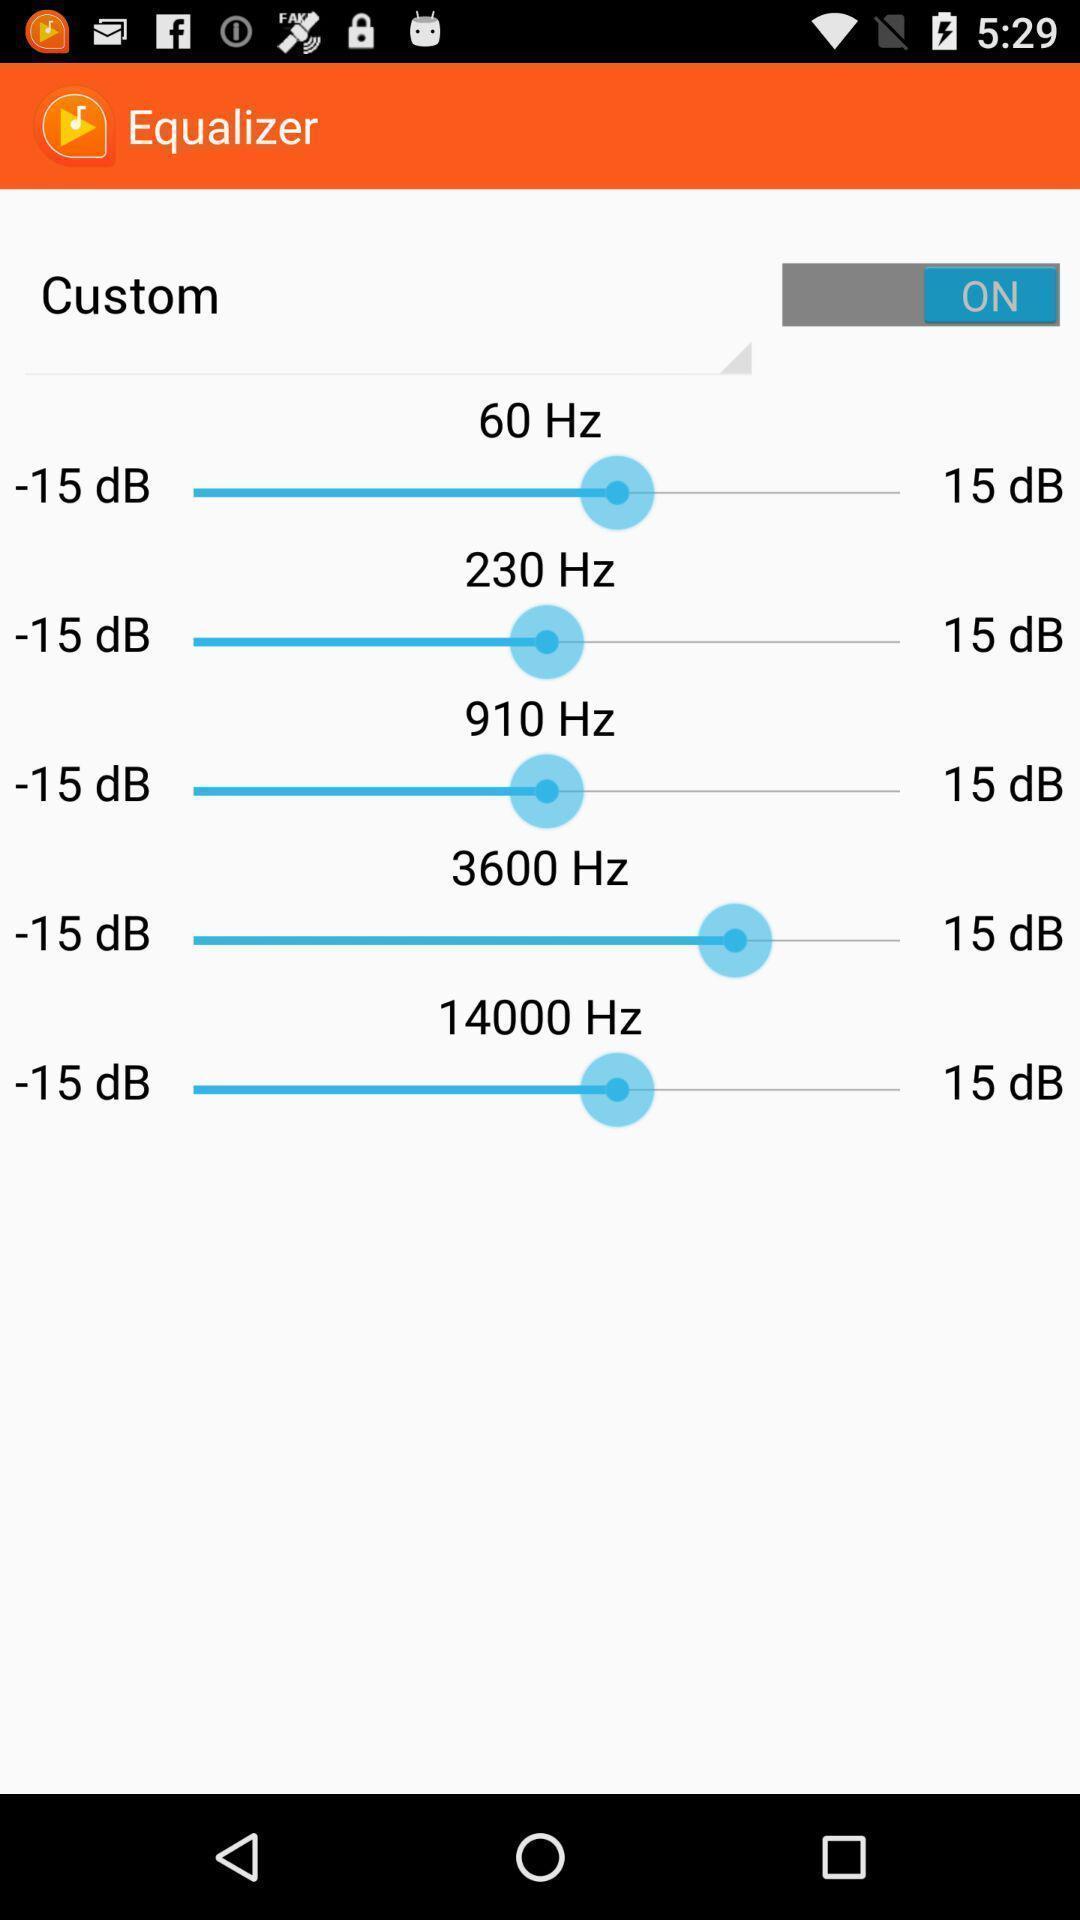Provide a description of this screenshot. Screen shows access for custom in an equalizer. 